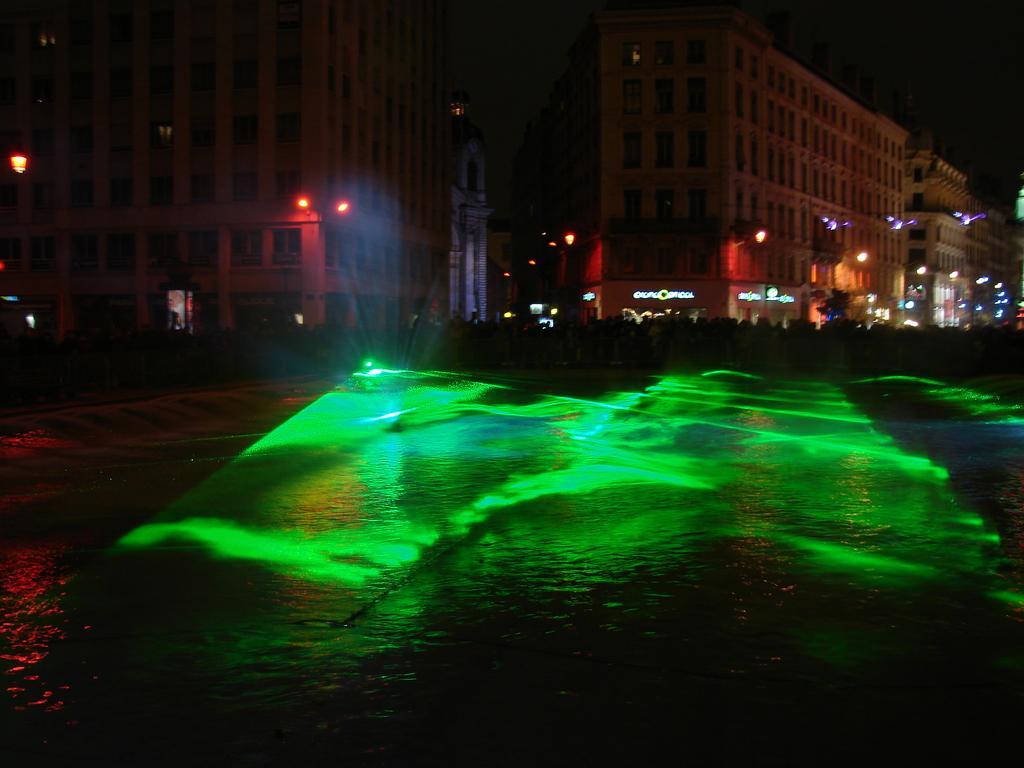In one or two sentences, can you explain what this image depicts? In this image, we can see buildings, lights and boards. At the bottom, there is water. 